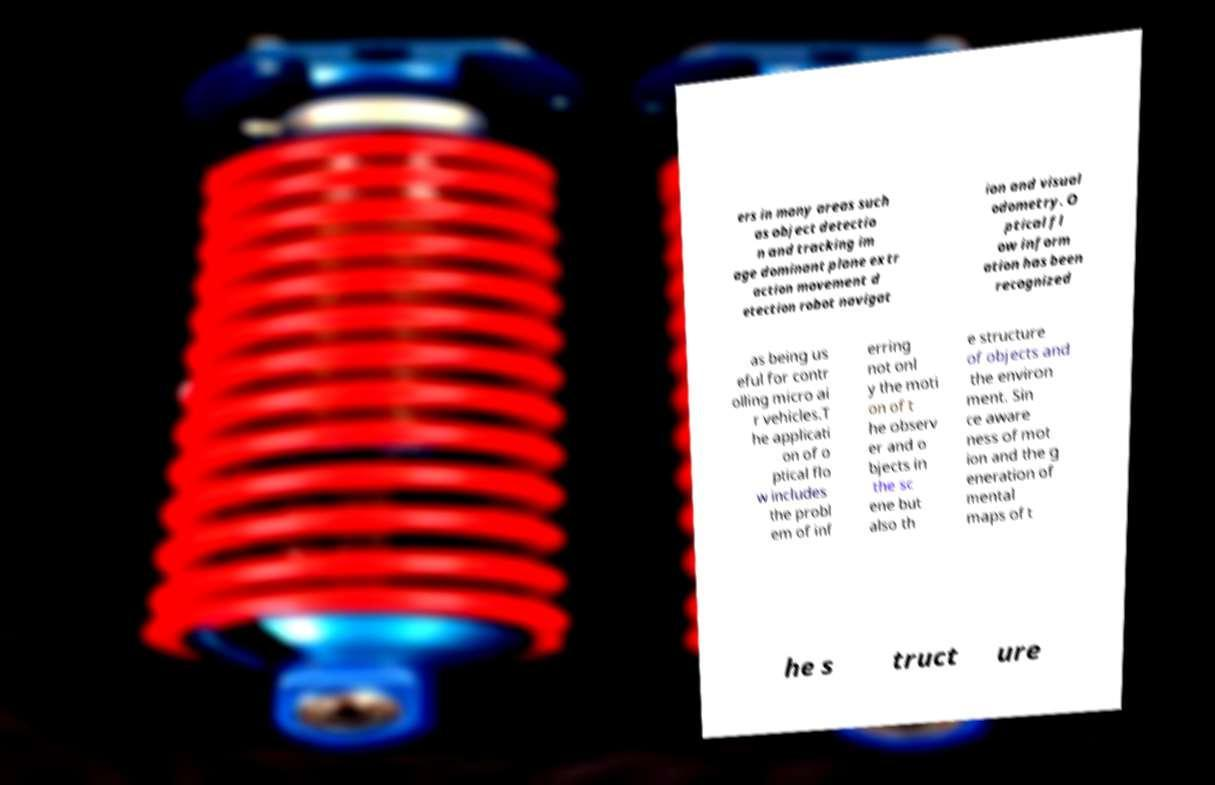Can you read and provide the text displayed in the image?This photo seems to have some interesting text. Can you extract and type it out for me? ers in many areas such as object detectio n and tracking im age dominant plane extr action movement d etection robot navigat ion and visual odometry. O ptical fl ow inform ation has been recognized as being us eful for contr olling micro ai r vehicles.T he applicati on of o ptical flo w includes the probl em of inf erring not onl y the moti on of t he observ er and o bjects in the sc ene but also th e structure of objects and the environ ment. Sin ce aware ness of mot ion and the g eneration of mental maps of t he s truct ure 